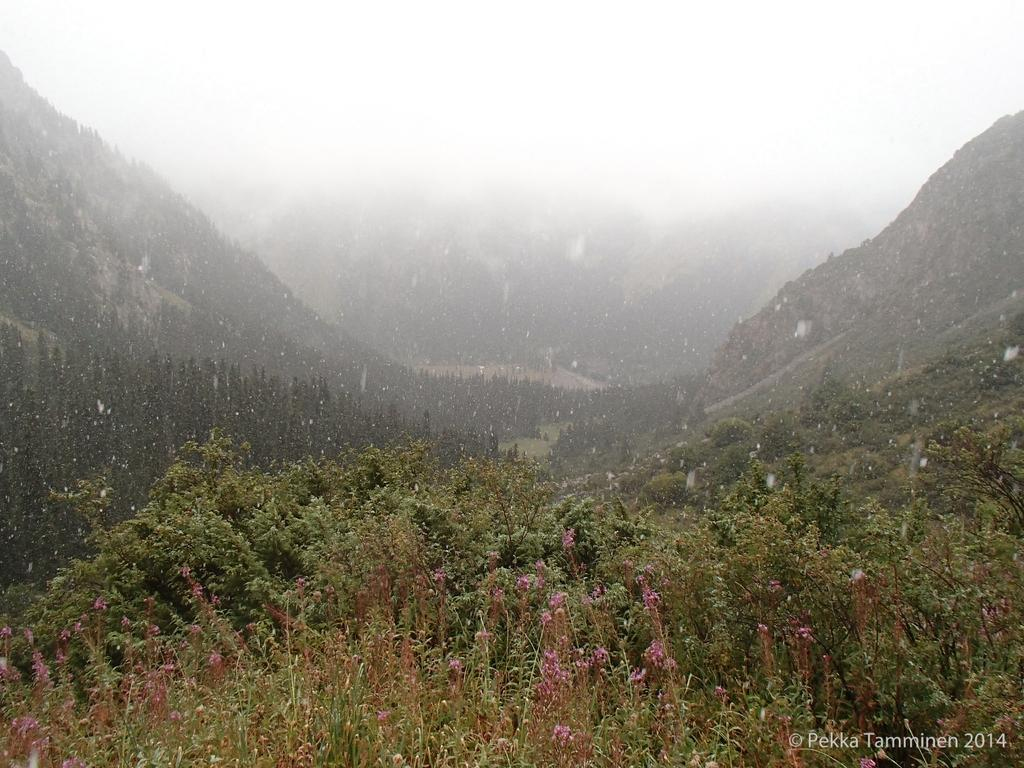What type of vegetation can be seen in the image? There are plants, trees, and flowers visible in the image. What is the weather like in the image? There is snow visible in the image, indicating a cold or wintery environment. What type of landscape is present in the image? There are mountains visible in the image, suggesting a mountainous or hilly terrain. What is visible in the sky in the image? The sky is visible in the image, but no specific weather conditions or clouds are mentioned. What color is the nail polish on the person's finger in the image? There is no person or nail polish present in the image; it features plants, trees, flowers, snow, mountains, and the sky. What type of alarm is going off in the image? There is no alarm present in the image; it features plants, trees, flowers, snow, mountains, and the sky. 